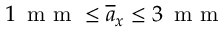Convert formula to latex. <formula><loc_0><loc_0><loc_500><loc_500>1 \, m m \leq \overline { a } _ { x } \leq 3 \, m m</formula> 